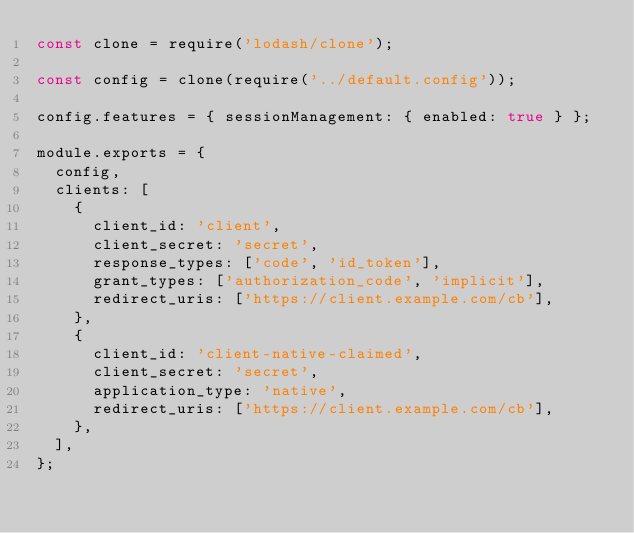<code> <loc_0><loc_0><loc_500><loc_500><_JavaScript_>const clone = require('lodash/clone');

const config = clone(require('../default.config'));

config.features = { sessionManagement: { enabled: true } };

module.exports = {
  config,
  clients: [
    {
      client_id: 'client',
      client_secret: 'secret',
      response_types: ['code', 'id_token'],
      grant_types: ['authorization_code', 'implicit'],
      redirect_uris: ['https://client.example.com/cb'],
    },
    {
      client_id: 'client-native-claimed',
      client_secret: 'secret',
      application_type: 'native',
      redirect_uris: ['https://client.example.com/cb'],
    },
  ],
};
</code> 